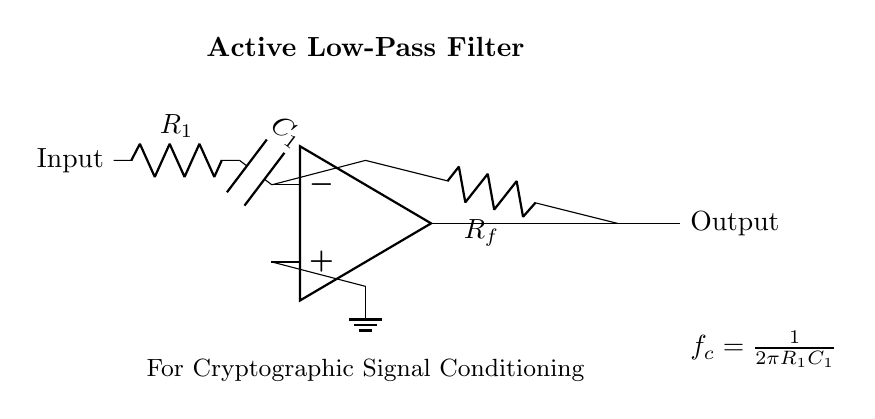What type of filter is illustrated in the circuit? The circuit shows an active low-pass filter, which is confirmed by the label at the top indicating its function.
Answer: Active low-pass filter What components are used in this circuit? The circuit includes an operational amplifier, a resistor labeled R1, a capacitor labeled C1, and a feedback resistor labeled Rf. These components can be identified from their symbols and labels in the diagram.
Answer: Operational amplifier, resistor, capacitor What is the formula for the cutoff frequency? The cutoff frequency is given by the formula shown in the diagram, which is f_c = \frac{1}{2\pi R_1C_1}. This is indicated by the label at the right side of the circuit diagram.
Answer: 1/(2πR1C1) How does the feedback affect the filter’s response? The feedback resistor Rf connects the output to the inverting input of the op-amp, influencing the gain and response of the filter. The feedback allows for tuning the filter characteristics, such as gain and bandwidth.
Answer: It affects gain and response What is the role of capacitor C1 in the circuit? Capacitor C1 allows low-frequency signals to pass while attenuating high-frequency signals, which is a key characteristic of low-pass filters. The capacitor's impedance decreases with increasing frequency, thus filtering out unwanted high-frequency components.
Answer: Filtering high frequencies Where does the ground connection go in this circuit? The ground connection is made to the non-inverting input of the operational amplifier, ensuring a reference point for the op-amp and stabilizing the circuit operation, as indicated by the ground symbol connected to the op-amp.
Answer: To the non-inverting input of the op-amp 